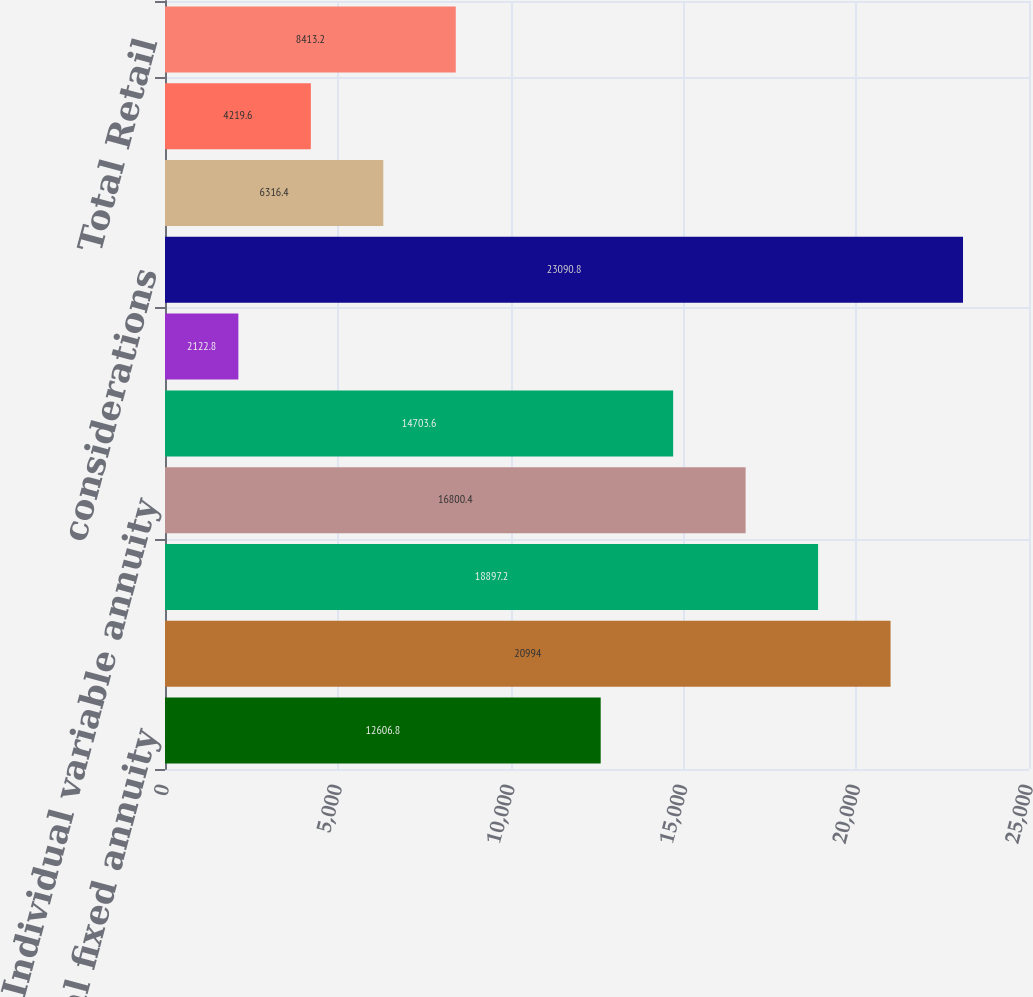Convert chart. <chart><loc_0><loc_0><loc_500><loc_500><bar_chart><fcel>Individual fixed annuity<fcel>Group retirement product<fcel>Life insurance<fcel>Individual variable annuity<fcel>Retail mutual funds<fcel>Individual annuities runoff<fcel>considerations<fcel>Retail - Independent<fcel>Retail - Affiliated (Career<fcel>Total Retail<nl><fcel>12606.8<fcel>20994<fcel>18897.2<fcel>16800.4<fcel>14703.6<fcel>2122.8<fcel>23090.8<fcel>6316.4<fcel>4219.6<fcel>8413.2<nl></chart> 